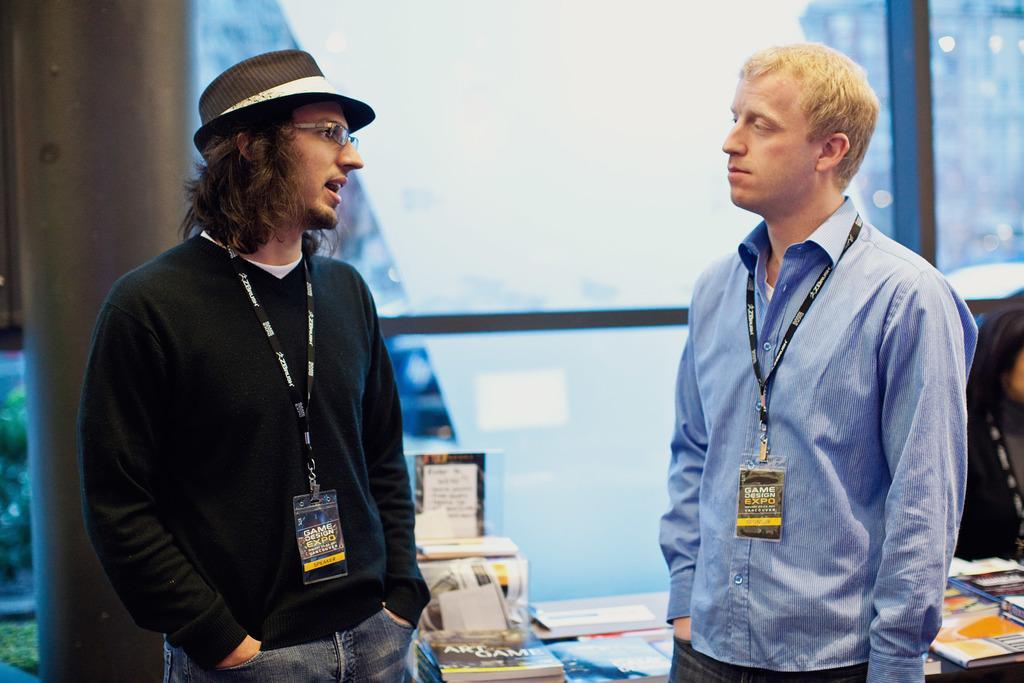Can you describe this image briefly? In this image, we can see two men are standing and looking at each other. Here a person is talking and wearing a hat and glasses. Background we can see pillars, glasses, books and few objects. On the right side of the image, we can see a person. 